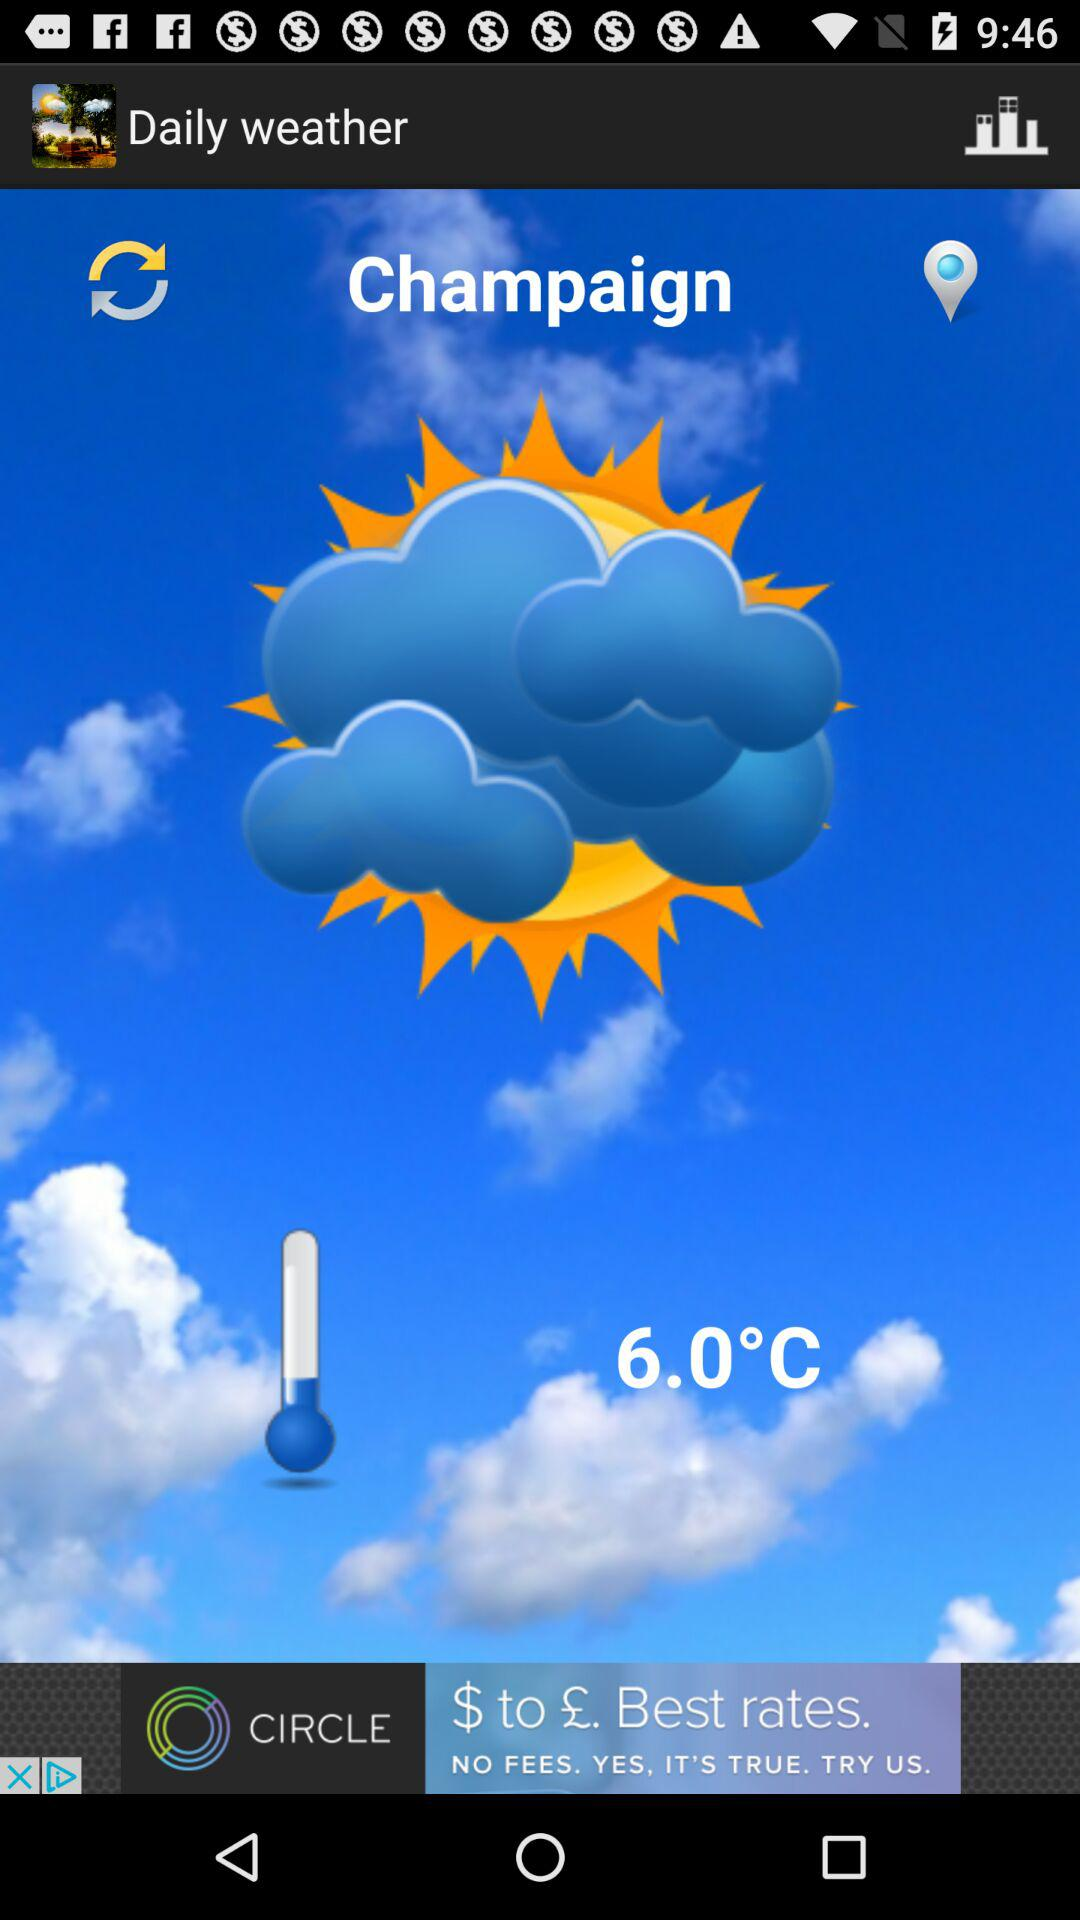What place is the temperature given for? The temperature is given for Champaign. 